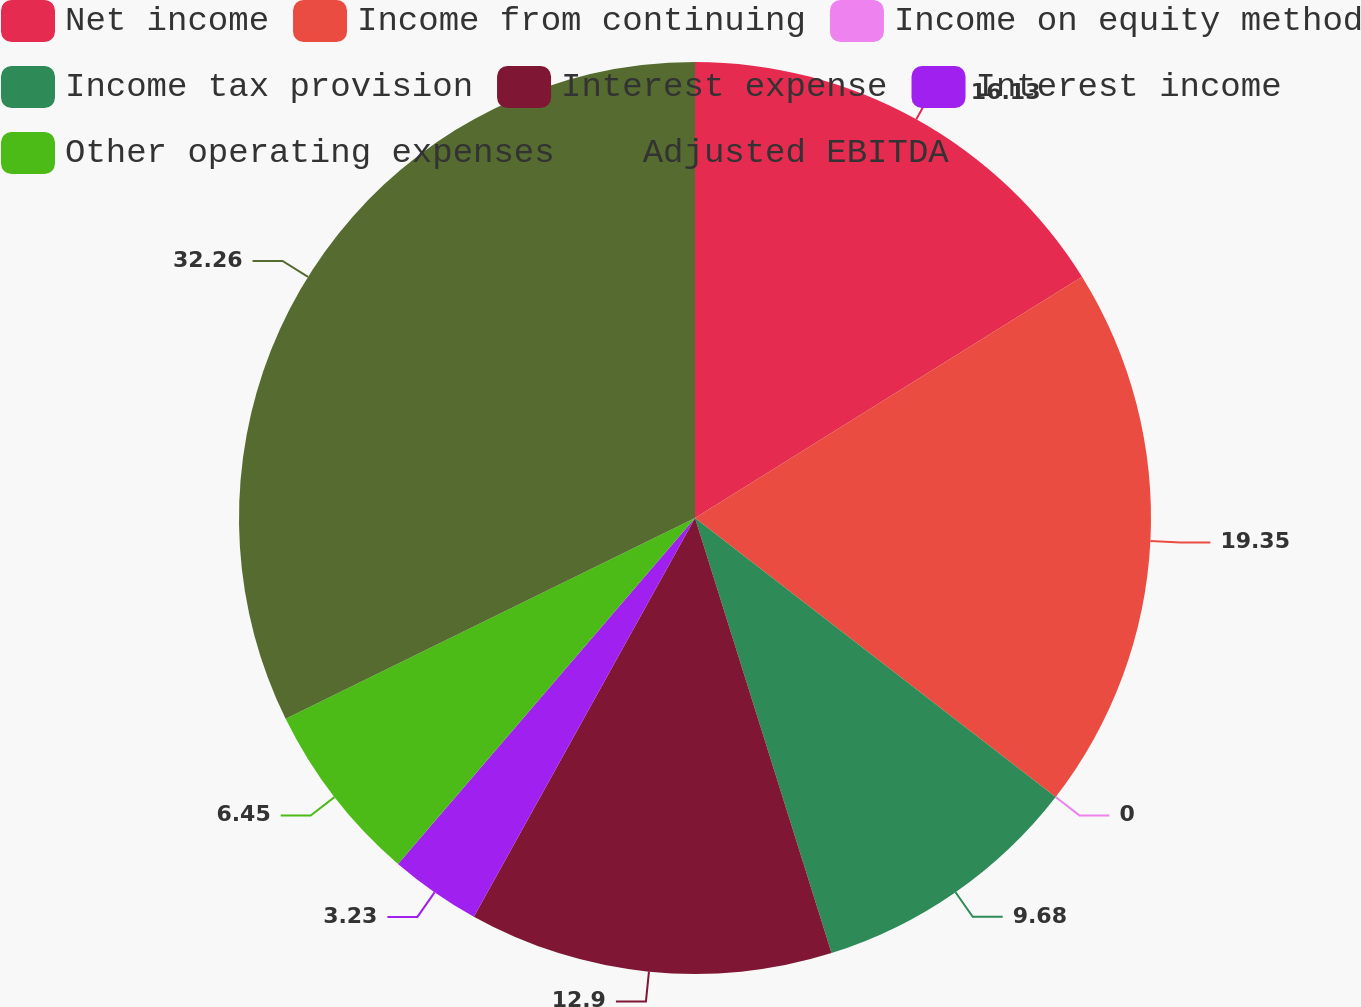Convert chart to OTSL. <chart><loc_0><loc_0><loc_500><loc_500><pie_chart><fcel>Net income<fcel>Income from continuing<fcel>Income on equity method<fcel>Income tax provision<fcel>Interest expense<fcel>Interest income<fcel>Other operating expenses<fcel>Adjusted EBITDA<nl><fcel>16.13%<fcel>19.35%<fcel>0.0%<fcel>9.68%<fcel>12.9%<fcel>3.23%<fcel>6.45%<fcel>32.26%<nl></chart> 